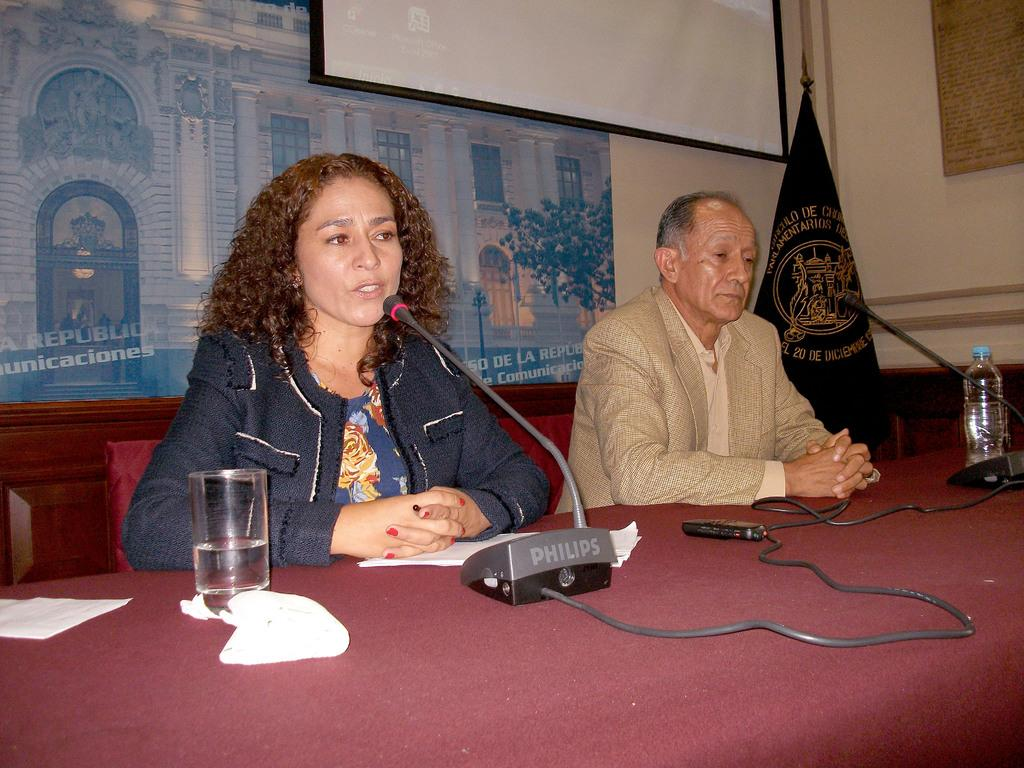What type of structure can be seen in the image? There is a wall in the image. What is hanging on the wall? There is a banner in the image. What is the main object in the center of the image? There is a screen in the image. How many people are present in the image? There are two people sitting on chairs in the image. What furniture is present in the image? There is a table in the image. What items can be seen on the table? There is a microphone, a glass, and a bottle on the table. What type of hill can be seen in the image? There is no hill present in the image. What type of cheese is being used to rub on the banner in the image? There is no cheese or rubbing action present in the image. 